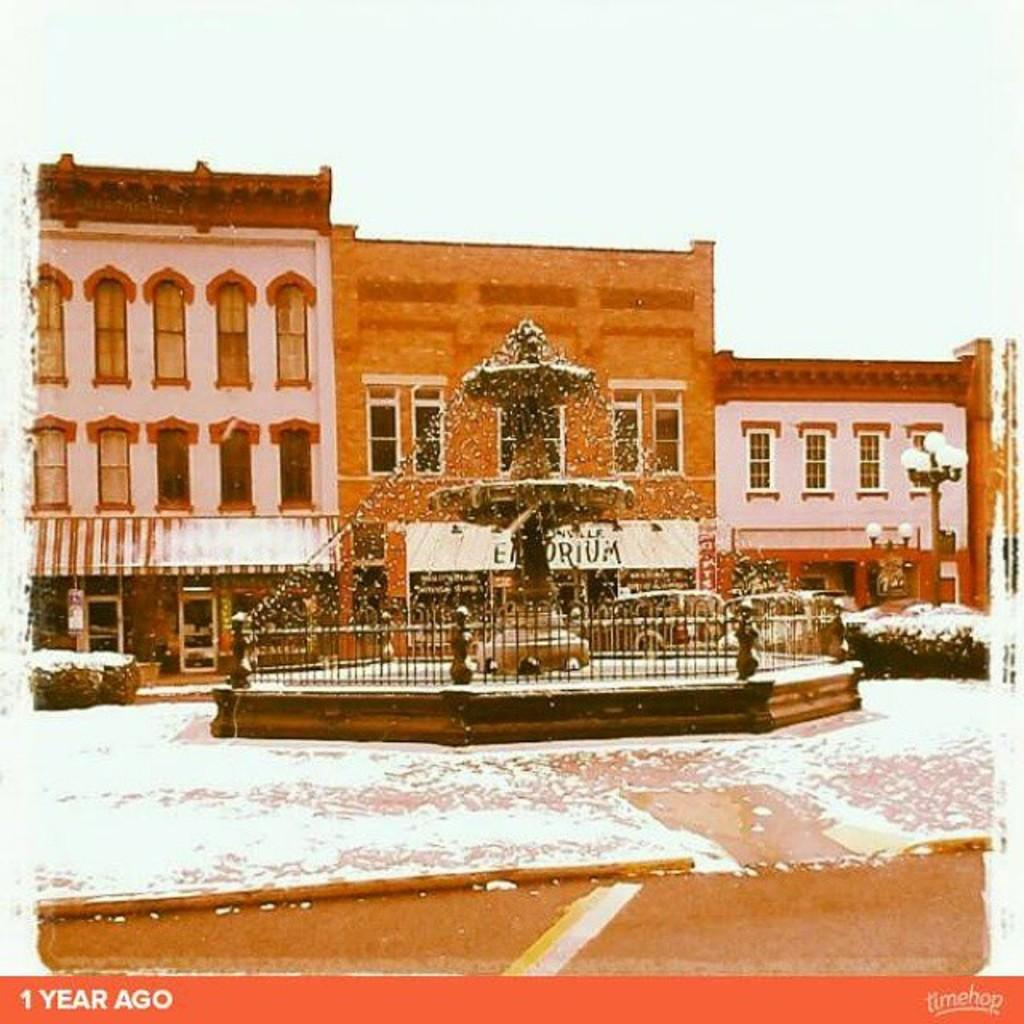What is the main feature in the image? There is a fountain in the image. What can be seen in the background of the image? There is a brown-colored building in the background. What structures are present in the image besides the fountain? There are light poles in the image. How would you describe the color of the sky in the image? The sky appears to be white in color. Who is the owner of the cabbage in the image? There is no cabbage present in the image. 